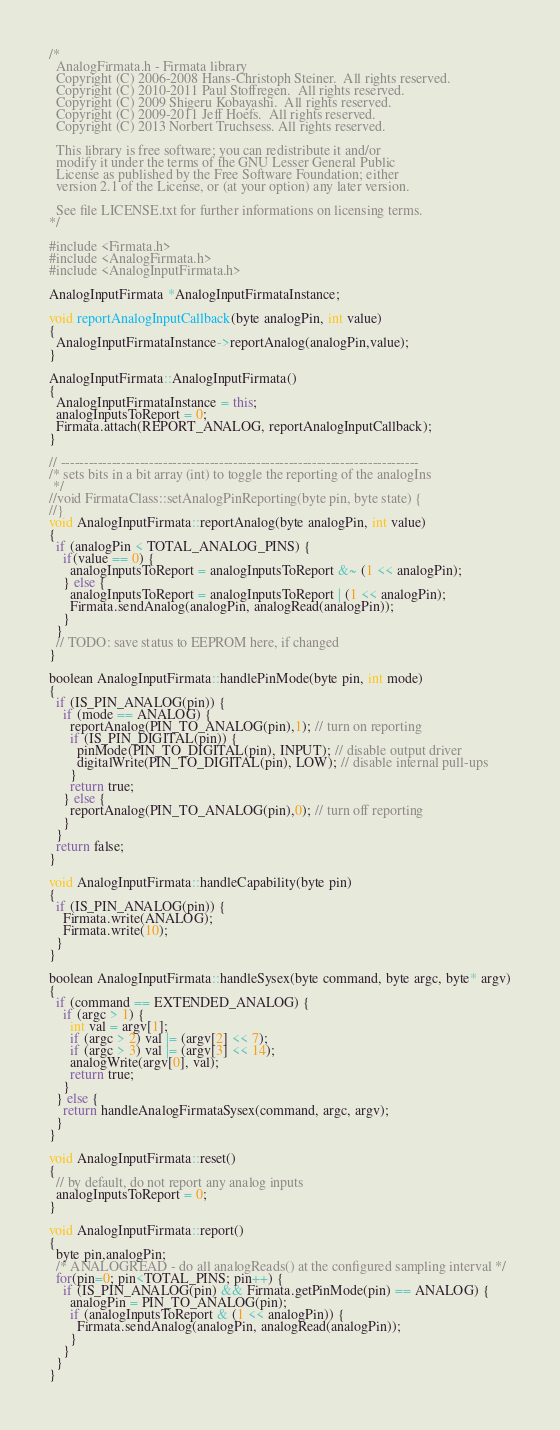<code> <loc_0><loc_0><loc_500><loc_500><_C++_>/*
  AnalogFirmata.h - Firmata library
  Copyright (C) 2006-2008 Hans-Christoph Steiner.  All rights reserved.
  Copyright (C) 2010-2011 Paul Stoffregen.  All rights reserved.
  Copyright (C) 2009 Shigeru Kobayashi.  All rights reserved.
  Copyright (C) 2009-2011 Jeff Hoefs.  All rights reserved.
  Copyright (C) 2013 Norbert Truchsess. All rights reserved.

  This library is free software; you can redistribute it and/or
  modify it under the terms of the GNU Lesser General Public
  License as published by the Free Software Foundation; either
  version 2.1 of the License, or (at your option) any later version.

  See file LICENSE.txt for further informations on licensing terms.
*/

#include <Firmata.h>
#include <AnalogFirmata.h>
#include <AnalogInputFirmata.h>

AnalogInputFirmata *AnalogInputFirmataInstance;

void reportAnalogInputCallback(byte analogPin, int value)
{
  AnalogInputFirmataInstance->reportAnalog(analogPin,value);
}

AnalogInputFirmata::AnalogInputFirmata()
{
  AnalogInputFirmataInstance = this;
  analogInputsToReport = 0;
  Firmata.attach(REPORT_ANALOG, reportAnalogInputCallback);
}

// -----------------------------------------------------------------------------
/* sets bits in a bit array (int) to toggle the reporting of the analogIns
 */
//void FirmataClass::setAnalogPinReporting(byte pin, byte state) {
//}
void AnalogInputFirmata::reportAnalog(byte analogPin, int value)
{
  if (analogPin < TOTAL_ANALOG_PINS) {
    if(value == 0) {
      analogInputsToReport = analogInputsToReport &~ (1 << analogPin);
    } else {
      analogInputsToReport = analogInputsToReport | (1 << analogPin);
      Firmata.sendAnalog(analogPin, analogRead(analogPin));
    }
  }
  // TODO: save status to EEPROM here, if changed
}

boolean AnalogInputFirmata::handlePinMode(byte pin, int mode)
{
  if (IS_PIN_ANALOG(pin)) {
    if (mode == ANALOG) {
      reportAnalog(PIN_TO_ANALOG(pin),1); // turn on reporting
      if (IS_PIN_DIGITAL(pin)) {
        pinMode(PIN_TO_DIGITAL(pin), INPUT); // disable output driver
        digitalWrite(PIN_TO_DIGITAL(pin), LOW); // disable internal pull-ups
      }
      return true;
    } else {
      reportAnalog(PIN_TO_ANALOG(pin),0); // turn off reporting
    }
  }
  return false;
}

void AnalogInputFirmata::handleCapability(byte pin)
{
  if (IS_PIN_ANALOG(pin)) {
    Firmata.write(ANALOG);
    Firmata.write(10);
  }
}

boolean AnalogInputFirmata::handleSysex(byte command, byte argc, byte* argv)
{
  if (command == EXTENDED_ANALOG) {
    if (argc > 1) {
      int val = argv[1];
      if (argc > 2) val |= (argv[2] << 7);
      if (argc > 3) val |= (argv[3] << 14);
      analogWrite(argv[0], val);
      return true;
    }
  } else {
    return handleAnalogFirmataSysex(command, argc, argv);
  }
}

void AnalogInputFirmata::reset()
{
  // by default, do not report any analog inputs
  analogInputsToReport = 0;
}

void AnalogInputFirmata::report()
{
  byte pin,analogPin;
  /* ANALOGREAD - do all analogReads() at the configured sampling interval */
  for(pin=0; pin<TOTAL_PINS; pin++) {
    if (IS_PIN_ANALOG(pin) && Firmata.getPinMode(pin) == ANALOG) {
      analogPin = PIN_TO_ANALOG(pin);
      if (analogInputsToReport & (1 << analogPin)) {
        Firmata.sendAnalog(analogPin, analogRead(analogPin));
      }
    }
  }
}
</code> 